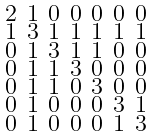Convert formula to latex. <formula><loc_0><loc_0><loc_500><loc_500>\begin{smallmatrix} 2 & 1 & 0 & 0 & 0 & 0 & 0 \\ 1 & 3 & 1 & 1 & 1 & 1 & 1 \\ 0 & 1 & 3 & 1 & 1 & 0 & 0 \\ 0 & 1 & 1 & 3 & 0 & 0 & 0 \\ 0 & 1 & 1 & 0 & 3 & 0 & 0 \\ 0 & 1 & 0 & 0 & 0 & 3 & 1 \\ 0 & 1 & 0 & 0 & 0 & 1 & 3 \end{smallmatrix}</formula> 